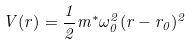Convert formula to latex. <formula><loc_0><loc_0><loc_500><loc_500>V ( r ) = \frac { 1 } { 2 } m ^ { * } \omega _ { 0 } ^ { 2 } ( r - r _ { 0 } ) ^ { 2 }</formula> 